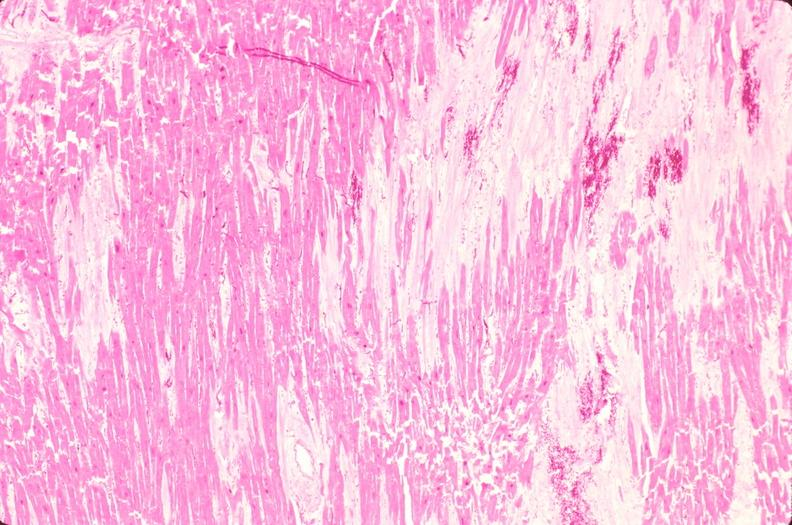where is this in?
Answer the question using a single word or phrase. In heart 